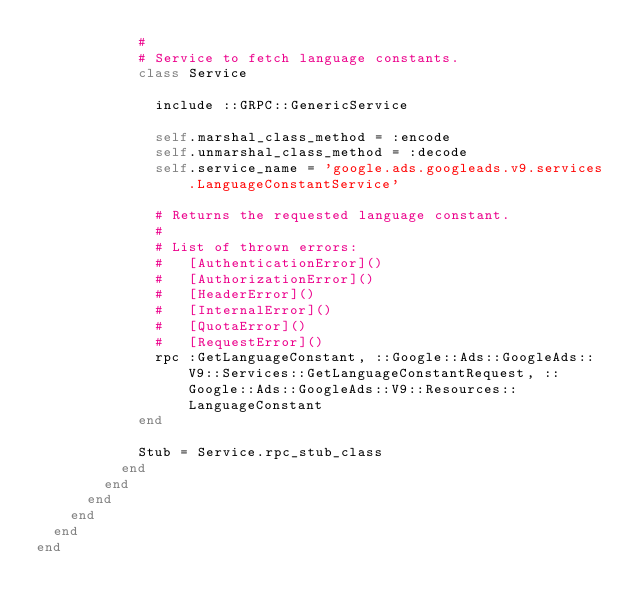Convert code to text. <code><loc_0><loc_0><loc_500><loc_500><_Ruby_>            #
            # Service to fetch language constants.
            class Service

              include ::GRPC::GenericService

              self.marshal_class_method = :encode
              self.unmarshal_class_method = :decode
              self.service_name = 'google.ads.googleads.v9.services.LanguageConstantService'

              # Returns the requested language constant.
              #
              # List of thrown errors:
              #   [AuthenticationError]()
              #   [AuthorizationError]()
              #   [HeaderError]()
              #   [InternalError]()
              #   [QuotaError]()
              #   [RequestError]()
              rpc :GetLanguageConstant, ::Google::Ads::GoogleAds::V9::Services::GetLanguageConstantRequest, ::Google::Ads::GoogleAds::V9::Resources::LanguageConstant
            end

            Stub = Service.rpc_stub_class
          end
        end
      end
    end
  end
end
</code> 